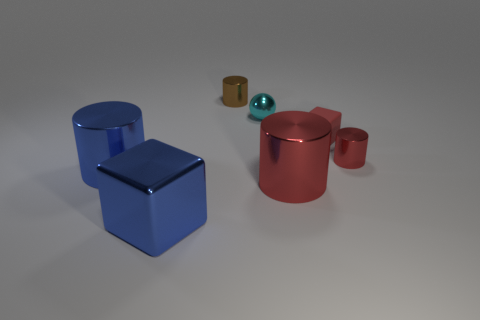The big blue thing in front of the big cylinder left of the large shiny cylinder to the right of the brown metal object is made of what material?
Make the answer very short. Metal. Are there fewer small balls than red metallic objects?
Keep it short and to the point. Yes. Does the small red cylinder have the same material as the small cyan thing?
Provide a succinct answer. Yes. There is a tiny cylinder that is in front of the small cyan sphere; is its color the same as the metal cube?
Provide a short and direct response. No. There is a large cylinder on the right side of the cyan object; what number of blue blocks are left of it?
Give a very brief answer. 1. There is a sphere that is the same size as the red matte cube; what color is it?
Your response must be concise. Cyan. There is a tiny cylinder left of the big red metallic object; what is it made of?
Your answer should be very brief. Metal. The thing that is behind the big cube and left of the small brown cylinder is made of what material?
Your answer should be very brief. Metal. Do the block left of the cyan metal ball and the tiny cyan object have the same size?
Keep it short and to the point. No. What is the shape of the small red shiny thing?
Provide a succinct answer. Cylinder. 